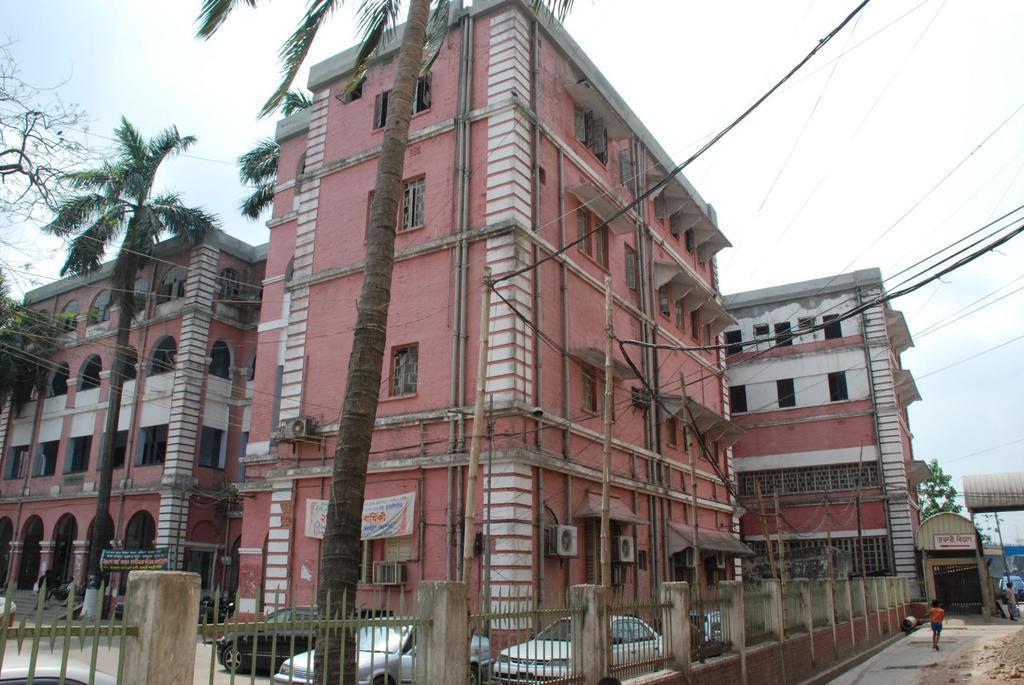Please provide a concise description of this image. In this picture I can see few buildings, trees, and I can see few cars and couple of banners and a board with some text and I can see a girl walking and I can see metal fence and a blue cloudy sky. 